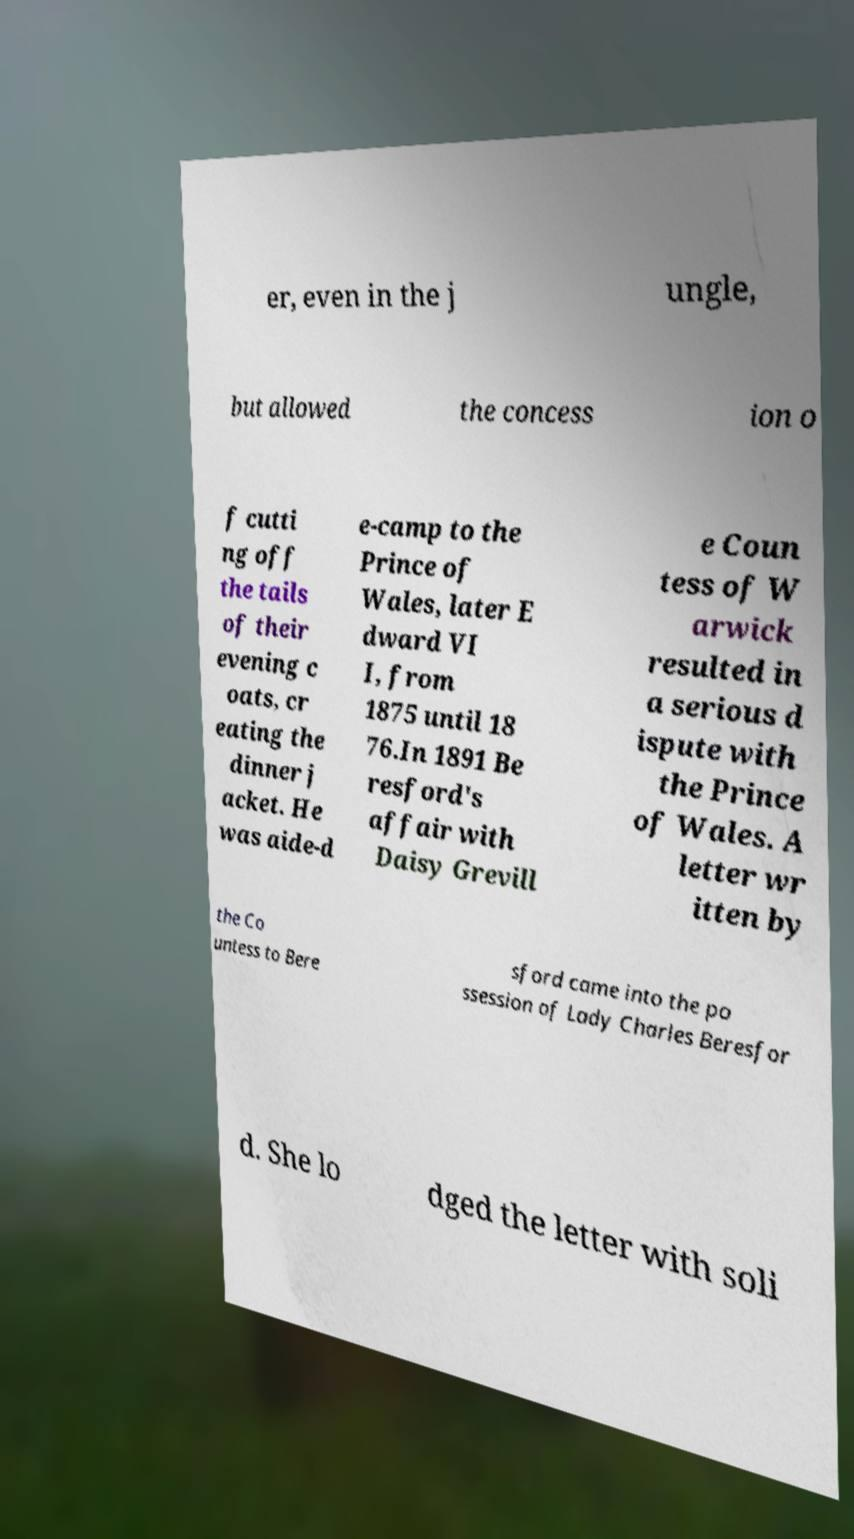Can you read and provide the text displayed in the image?This photo seems to have some interesting text. Can you extract and type it out for me? er, even in the j ungle, but allowed the concess ion o f cutti ng off the tails of their evening c oats, cr eating the dinner j acket. He was aide-d e-camp to the Prince of Wales, later E dward VI I, from 1875 until 18 76.In 1891 Be resford's affair with Daisy Grevill e Coun tess of W arwick resulted in a serious d ispute with the Prince of Wales. A letter wr itten by the Co untess to Bere sford came into the po ssession of Lady Charles Beresfor d. She lo dged the letter with soli 